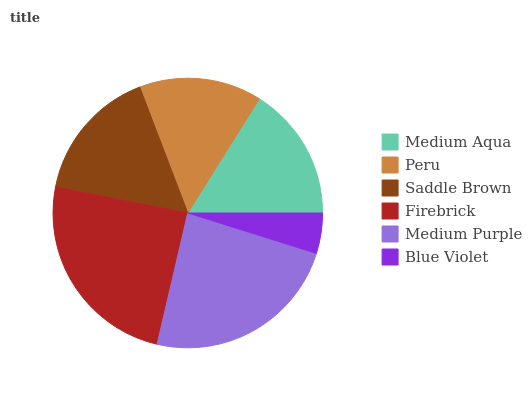Is Blue Violet the minimum?
Answer yes or no. Yes. Is Firebrick the maximum?
Answer yes or no. Yes. Is Peru the minimum?
Answer yes or no. No. Is Peru the maximum?
Answer yes or no. No. Is Medium Aqua greater than Peru?
Answer yes or no. Yes. Is Peru less than Medium Aqua?
Answer yes or no. Yes. Is Peru greater than Medium Aqua?
Answer yes or no. No. Is Medium Aqua less than Peru?
Answer yes or no. No. Is Saddle Brown the high median?
Answer yes or no. Yes. Is Medium Aqua the low median?
Answer yes or no. Yes. Is Medium Purple the high median?
Answer yes or no. No. Is Firebrick the low median?
Answer yes or no. No. 